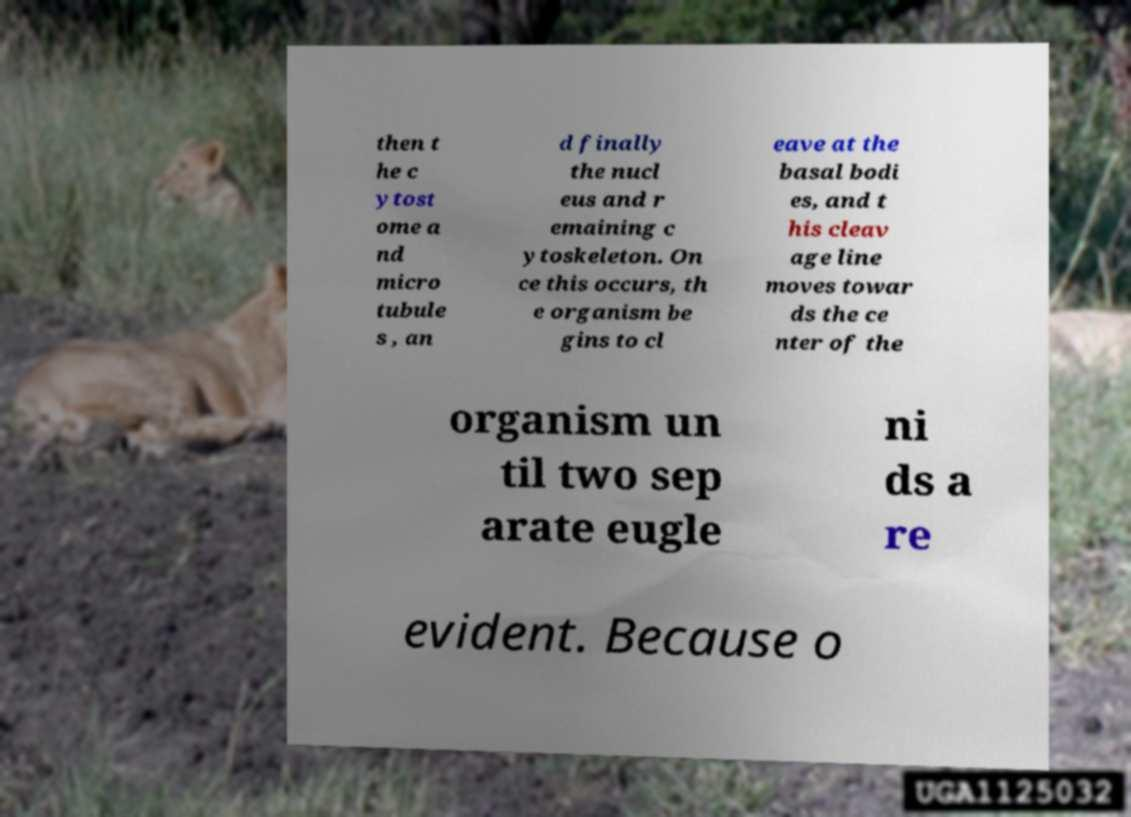Please identify and transcribe the text found in this image. then t he c ytost ome a nd micro tubule s , an d finally the nucl eus and r emaining c ytoskeleton. On ce this occurs, th e organism be gins to cl eave at the basal bodi es, and t his cleav age line moves towar ds the ce nter of the organism un til two sep arate eugle ni ds a re evident. Because o 